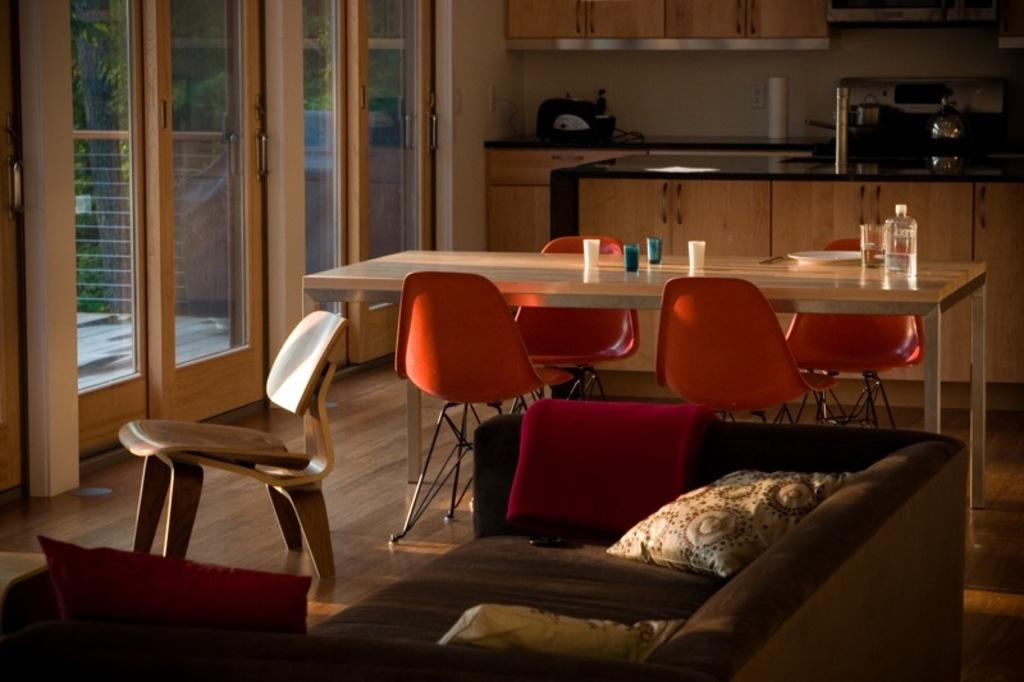What type of furniture is present in the image? There is a table, chairs, and a sofa in the image. What can be found on the sofa? There are pillows on the sofa. What is visible in the background of the image? There is a glass door and a cupboard in the background of the image. What type of cheese does the aunt bring in the image? There is no aunt or cheese mentioned in the image. 